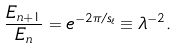<formula> <loc_0><loc_0><loc_500><loc_500>\frac { E _ { n + 1 } } { E _ { n } } = e ^ { - 2 \pi / s _ { \ell } } \equiv \lambda ^ { - 2 } .</formula> 